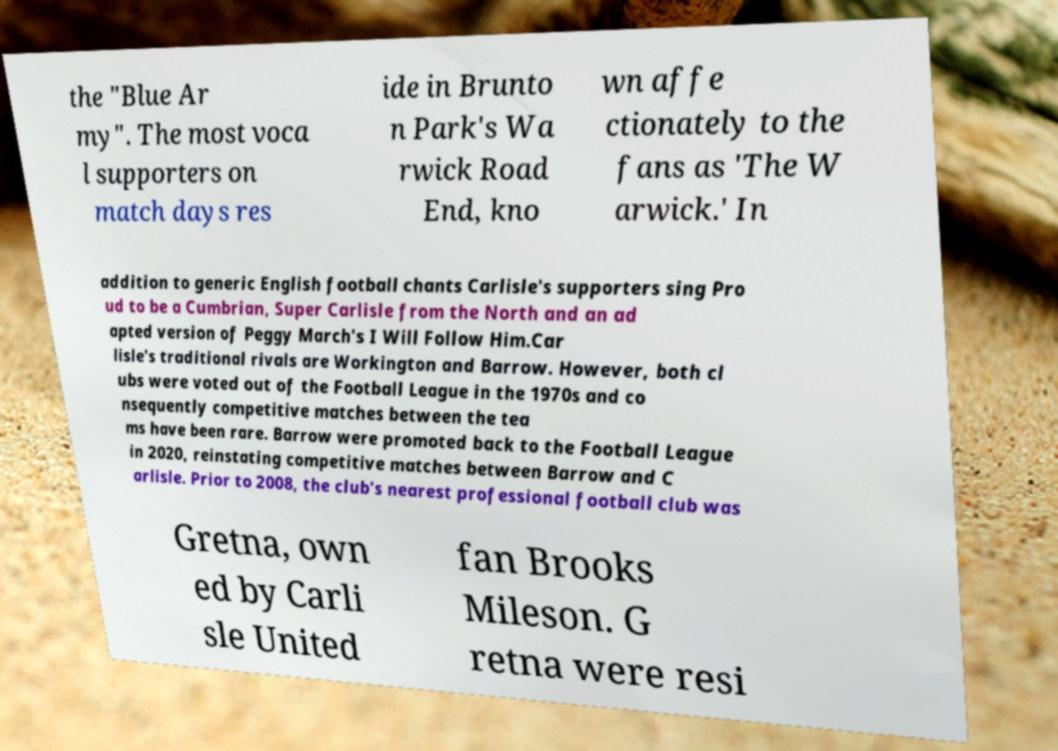Please read and relay the text visible in this image. What does it say? the "Blue Ar my". The most voca l supporters on match days res ide in Brunto n Park's Wa rwick Road End, kno wn affe ctionately to the fans as 'The W arwick.' In addition to generic English football chants Carlisle's supporters sing Pro ud to be a Cumbrian, Super Carlisle from the North and an ad apted version of Peggy March's I Will Follow Him.Car lisle's traditional rivals are Workington and Barrow. However, both cl ubs were voted out of the Football League in the 1970s and co nsequently competitive matches between the tea ms have been rare. Barrow were promoted back to the Football League in 2020, reinstating competitive matches between Barrow and C arlisle. Prior to 2008, the club's nearest professional football club was Gretna, own ed by Carli sle United fan Brooks Mileson. G retna were resi 